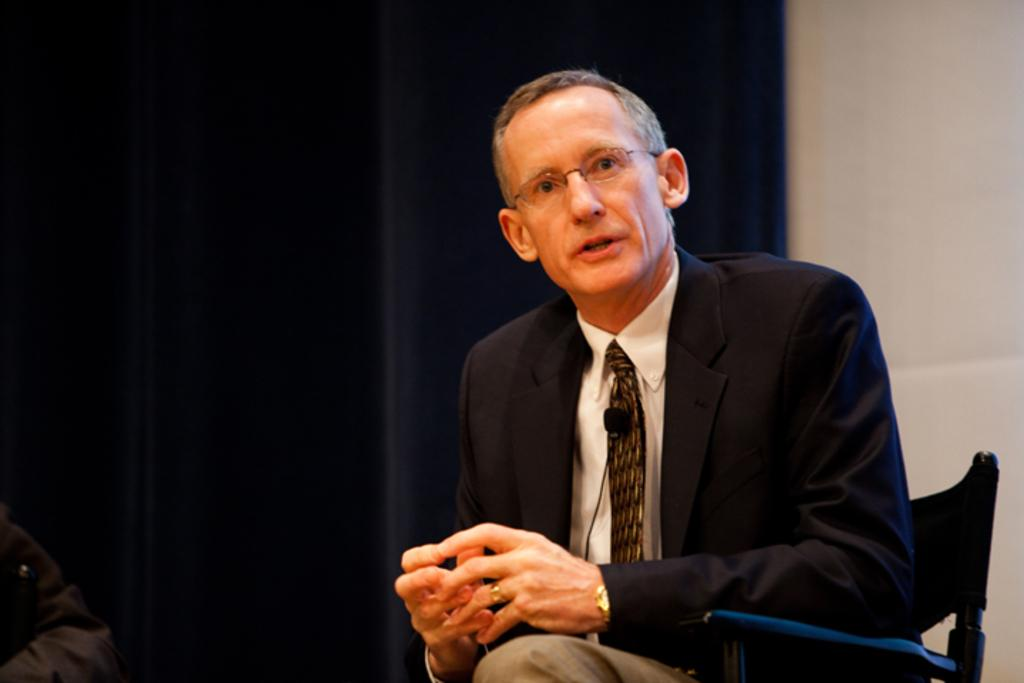What is the man in the image doing? The man is sitting on a chair in the image. What is the man wearing on his upper body? The man is wearing a blue blazer and a white shirt. What is the man wearing around his neck? The man is wearing a brown tie. What is the man wearing on his lower body? The man is wearing cream pants. What can be seen in the background of the image? There is a black curtain and a white wall in the background of the image. How many units of soap can be seen in the image? There is no soap present in the image. Is the man in the image preparing for a flight? There is no indication in the image that the man is preparing for a flight. 